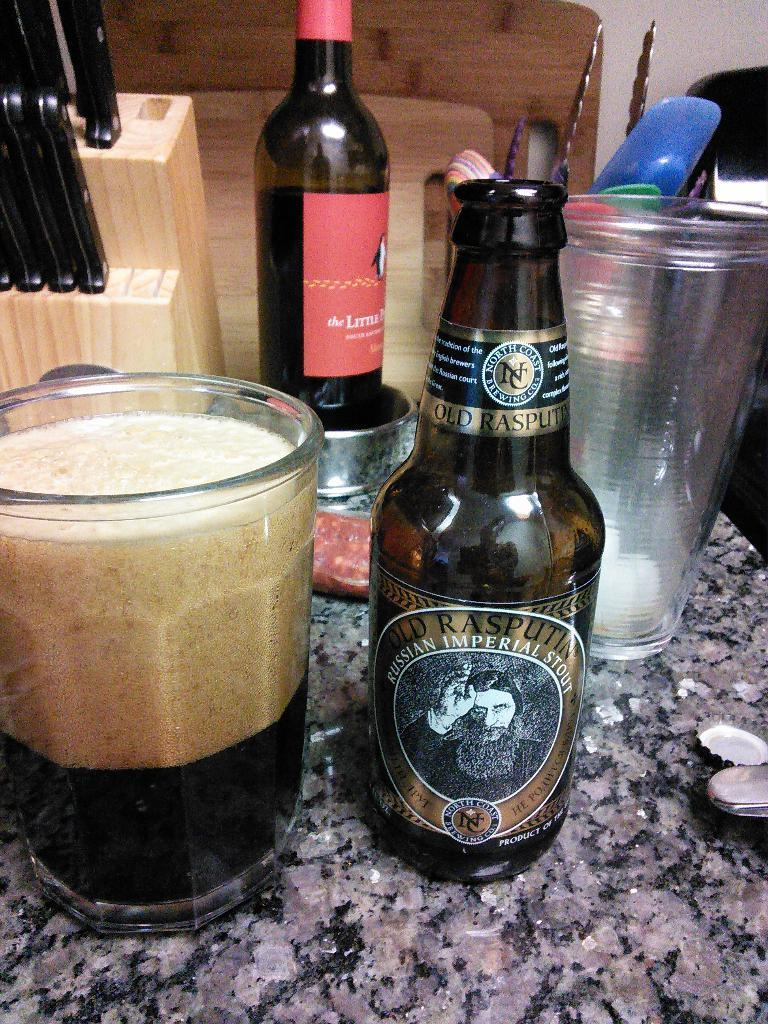<image>
Summarize the visual content of the image. Bottle of alcohol which says "Russian Imperial Stout" next to a cup. 